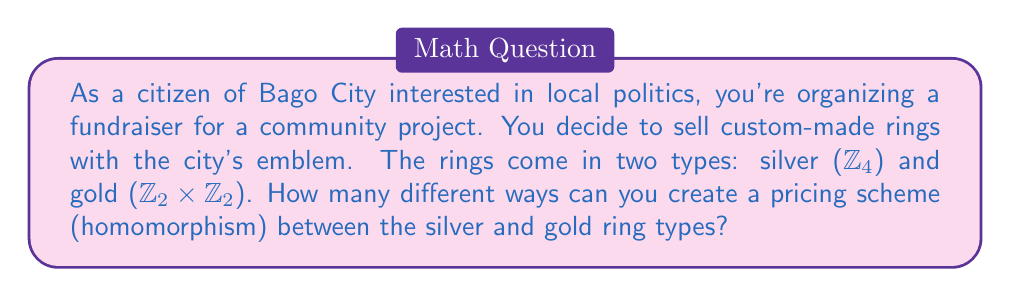Can you solve this math problem? To solve this problem, we need to calculate the number of homomorphisms from $\mathbb{Z}_4$ to $\mathbb{Z}_2 \times \mathbb{Z}_2$. Let's approach this step-by-step:

1) First, recall that a ring homomorphism $f: \mathbb{Z}_4 \rightarrow \mathbb{Z}_2 \times \mathbb{Z}_2$ must satisfy:
   a) $f(a+b) = f(a) + f(b)$ for all $a,b \in \mathbb{Z}_4$
   b) $f(ab) = f(a)f(b)$ for all $a,b \in \mathbb{Z}_4$
   c) $f(1) = 1$ (the multiplicative identity must be preserved)

2) In $\mathbb{Z}_4$, the element 1 generates the whole ring additively. So, if we know $f(1)$, we can determine the entire homomorphism.

3) In $\mathbb{Z}_2 \times \mathbb{Z}_2$, the possible values for $f(1)$ that satisfy $f(1) + f(1) + f(1) + f(1) = 0$ are:
   $(0,0)$, $(1,0)$, $(0,1)$, $(1,1)$

4) However, $f(1)$ must also be a unit (have a multiplicative inverse) in $\mathbb{Z}_2 \times \mathbb{Z}_2$ to preserve the multiplicative identity.

5) The units in $\mathbb{Z}_2 \times \mathbb{Z}_2$ are $(1,0)$, $(0,1)$, and $(1,1)$.

6) Therefore, we have three possible choices for $f(1)$:
   - $f(1) = (1,0)$
   - $f(1) = (0,1)$
   - $f(1) = (1,1)$

7) Each of these choices uniquely determines a homomorphism:
   - If $f(1) = (1,0)$, then $f(2) = (0,0)$, $f(3) = (1,0)$
   - If $f(1) = (0,1)$, then $f(2) = (0,0)$, $f(3) = (0,1)$
   - If $f(1) = (1,1)$, then $f(2) = (0,0)$, $f(3) = (1,1)$

Thus, there are exactly 3 homomorphisms from $\mathbb{Z}_4$ to $\mathbb{Z}_2 \times \mathbb{Z}_2$.
Answer: 3 